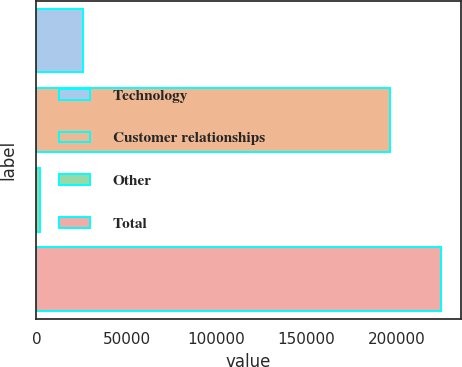<chart> <loc_0><loc_0><loc_500><loc_500><bar_chart><fcel>Technology<fcel>Customer relationships<fcel>Other<fcel>Total<nl><fcel>26100<fcel>196400<fcel>1970<fcel>224470<nl></chart> 